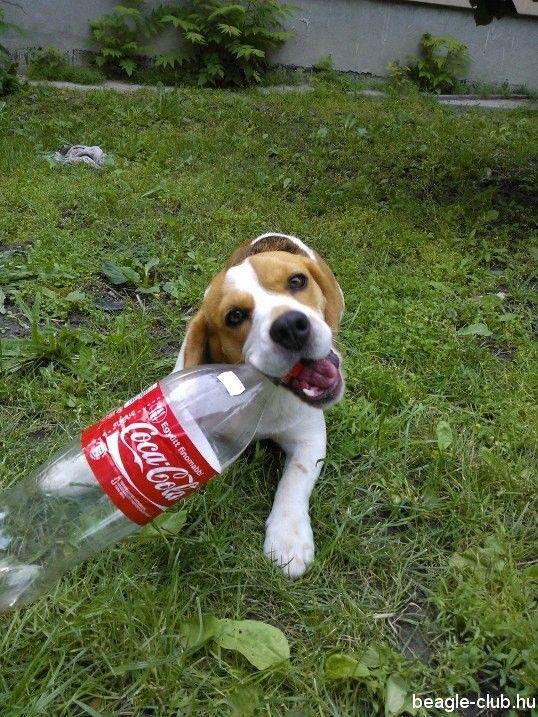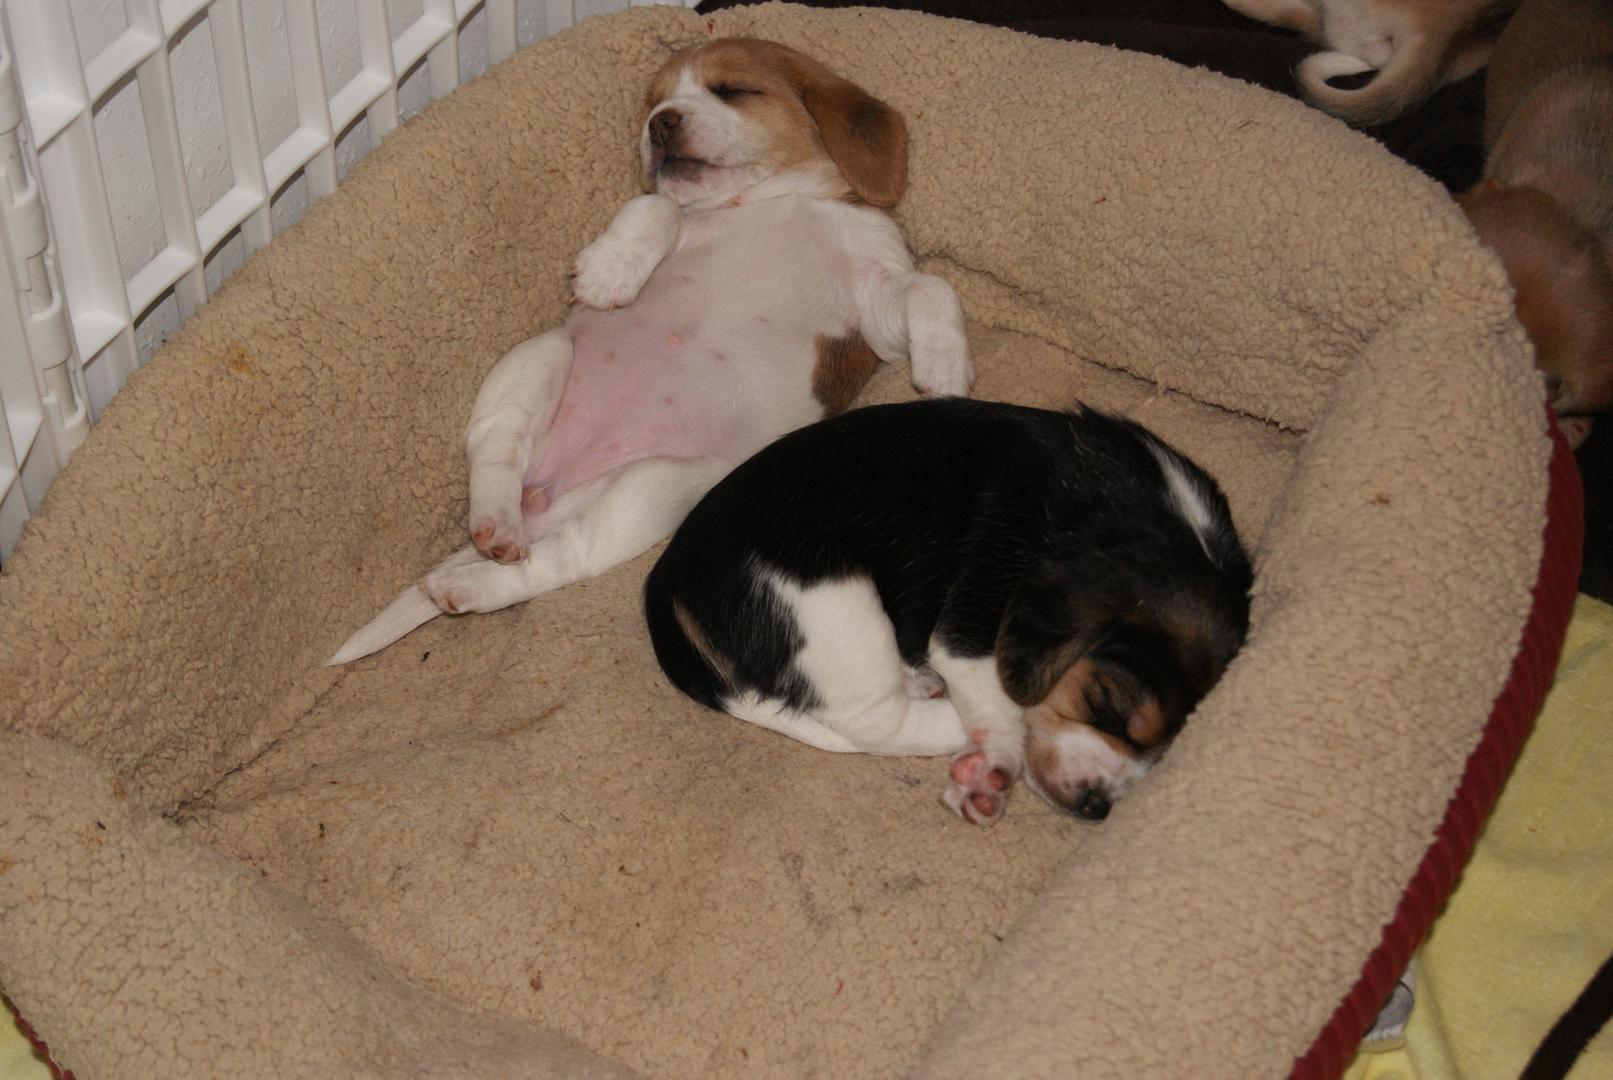The first image is the image on the left, the second image is the image on the right. For the images shown, is this caption "One image shows a beagle outdoors on grass, with its mouth next to a plastic object that is at least partly bright red." true? Answer yes or no. Yes. 